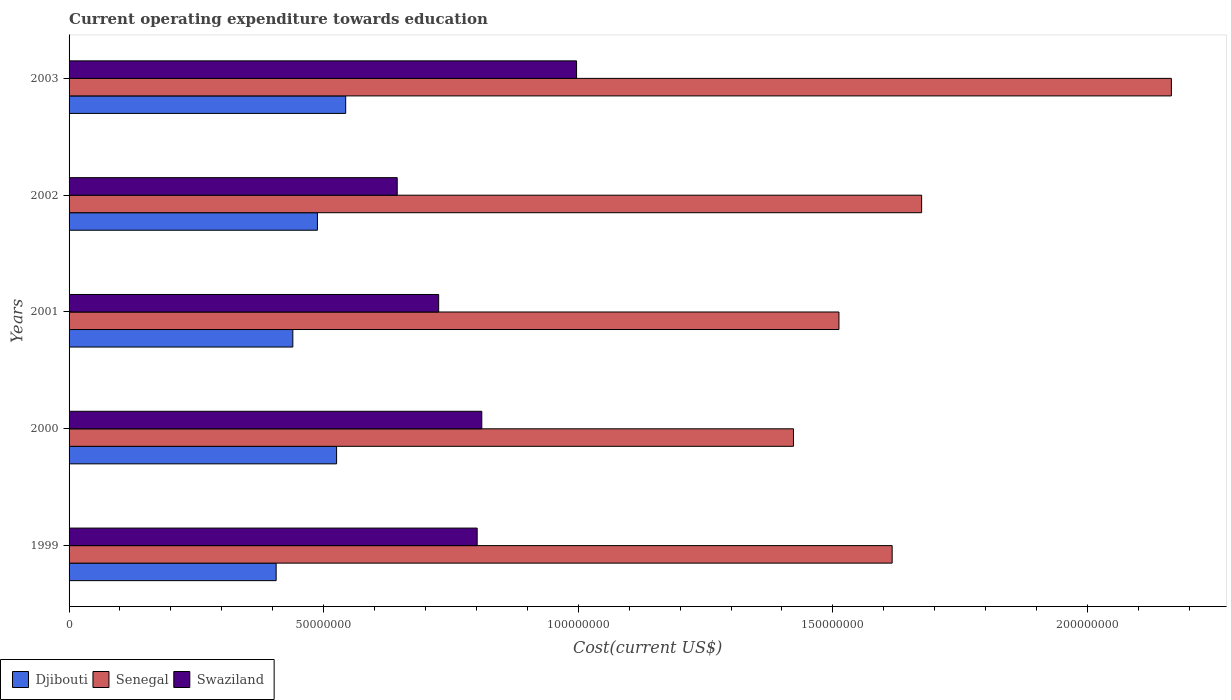In how many cases, is the number of bars for a given year not equal to the number of legend labels?
Ensure brevity in your answer.  0. What is the expenditure towards education in Senegal in 2000?
Ensure brevity in your answer.  1.42e+08. Across all years, what is the maximum expenditure towards education in Swaziland?
Provide a succinct answer. 9.97e+07. Across all years, what is the minimum expenditure towards education in Djibouti?
Provide a short and direct response. 4.07e+07. What is the total expenditure towards education in Swaziland in the graph?
Provide a short and direct response. 3.98e+08. What is the difference between the expenditure towards education in Swaziland in 1999 and that in 2001?
Offer a terse response. 7.56e+06. What is the difference between the expenditure towards education in Swaziland in 1999 and the expenditure towards education in Djibouti in 2002?
Your answer should be very brief. 3.14e+07. What is the average expenditure towards education in Senegal per year?
Your response must be concise. 1.68e+08. In the year 2002, what is the difference between the expenditure towards education in Djibouti and expenditure towards education in Senegal?
Provide a succinct answer. -1.19e+08. In how many years, is the expenditure towards education in Swaziland greater than 80000000 US$?
Keep it short and to the point. 3. What is the ratio of the expenditure towards education in Swaziland in 1999 to that in 2001?
Provide a succinct answer. 1.1. Is the expenditure towards education in Senegal in 1999 less than that in 2002?
Make the answer very short. Yes. Is the difference between the expenditure towards education in Djibouti in 2000 and 2003 greater than the difference between the expenditure towards education in Senegal in 2000 and 2003?
Your answer should be very brief. Yes. What is the difference between the highest and the second highest expenditure towards education in Swaziland?
Ensure brevity in your answer.  1.86e+07. What is the difference between the highest and the lowest expenditure towards education in Senegal?
Your response must be concise. 7.42e+07. What does the 3rd bar from the top in 2000 represents?
Provide a short and direct response. Djibouti. What does the 3rd bar from the bottom in 2003 represents?
Ensure brevity in your answer.  Swaziland. Is it the case that in every year, the sum of the expenditure towards education in Djibouti and expenditure towards education in Senegal is greater than the expenditure towards education in Swaziland?
Provide a short and direct response. Yes. How many bars are there?
Offer a very short reply. 15. Are all the bars in the graph horizontal?
Your answer should be very brief. Yes. How many years are there in the graph?
Provide a succinct answer. 5. Does the graph contain any zero values?
Give a very brief answer. No. What is the title of the graph?
Make the answer very short. Current operating expenditure towards education. Does "St. Martin (French part)" appear as one of the legend labels in the graph?
Make the answer very short. No. What is the label or title of the X-axis?
Give a very brief answer. Cost(current US$). What is the label or title of the Y-axis?
Your answer should be compact. Years. What is the Cost(current US$) of Djibouti in 1999?
Offer a terse response. 4.07e+07. What is the Cost(current US$) of Senegal in 1999?
Your answer should be very brief. 1.62e+08. What is the Cost(current US$) in Swaziland in 1999?
Provide a short and direct response. 8.01e+07. What is the Cost(current US$) of Djibouti in 2000?
Your response must be concise. 5.25e+07. What is the Cost(current US$) in Senegal in 2000?
Provide a succinct answer. 1.42e+08. What is the Cost(current US$) in Swaziland in 2000?
Provide a short and direct response. 8.11e+07. What is the Cost(current US$) in Djibouti in 2001?
Ensure brevity in your answer.  4.39e+07. What is the Cost(current US$) of Senegal in 2001?
Provide a short and direct response. 1.51e+08. What is the Cost(current US$) of Swaziland in 2001?
Keep it short and to the point. 7.26e+07. What is the Cost(current US$) of Djibouti in 2002?
Offer a very short reply. 4.88e+07. What is the Cost(current US$) in Senegal in 2002?
Ensure brevity in your answer.  1.67e+08. What is the Cost(current US$) of Swaziland in 2002?
Offer a terse response. 6.44e+07. What is the Cost(current US$) in Djibouti in 2003?
Your answer should be compact. 5.43e+07. What is the Cost(current US$) of Senegal in 2003?
Make the answer very short. 2.16e+08. What is the Cost(current US$) in Swaziland in 2003?
Your answer should be compact. 9.97e+07. Across all years, what is the maximum Cost(current US$) of Djibouti?
Offer a terse response. 5.43e+07. Across all years, what is the maximum Cost(current US$) in Senegal?
Give a very brief answer. 2.16e+08. Across all years, what is the maximum Cost(current US$) of Swaziland?
Offer a very short reply. 9.97e+07. Across all years, what is the minimum Cost(current US$) of Djibouti?
Provide a short and direct response. 4.07e+07. Across all years, what is the minimum Cost(current US$) in Senegal?
Provide a short and direct response. 1.42e+08. Across all years, what is the minimum Cost(current US$) in Swaziland?
Provide a succinct answer. 6.44e+07. What is the total Cost(current US$) of Djibouti in the graph?
Make the answer very short. 2.40e+08. What is the total Cost(current US$) in Senegal in the graph?
Keep it short and to the point. 8.39e+08. What is the total Cost(current US$) of Swaziland in the graph?
Your answer should be compact. 3.98e+08. What is the difference between the Cost(current US$) of Djibouti in 1999 and that in 2000?
Provide a succinct answer. -1.19e+07. What is the difference between the Cost(current US$) in Senegal in 1999 and that in 2000?
Provide a short and direct response. 1.94e+07. What is the difference between the Cost(current US$) in Swaziland in 1999 and that in 2000?
Provide a short and direct response. -9.08e+05. What is the difference between the Cost(current US$) in Djibouti in 1999 and that in 2001?
Keep it short and to the point. -3.27e+06. What is the difference between the Cost(current US$) of Senegal in 1999 and that in 2001?
Make the answer very short. 1.04e+07. What is the difference between the Cost(current US$) in Swaziland in 1999 and that in 2001?
Make the answer very short. 7.56e+06. What is the difference between the Cost(current US$) in Djibouti in 1999 and that in 2002?
Offer a very short reply. -8.11e+06. What is the difference between the Cost(current US$) of Senegal in 1999 and that in 2002?
Ensure brevity in your answer.  -5.79e+06. What is the difference between the Cost(current US$) of Swaziland in 1999 and that in 2002?
Your answer should be very brief. 1.57e+07. What is the difference between the Cost(current US$) of Djibouti in 1999 and that in 2003?
Your answer should be compact. -1.37e+07. What is the difference between the Cost(current US$) of Senegal in 1999 and that in 2003?
Your answer should be compact. -5.48e+07. What is the difference between the Cost(current US$) in Swaziland in 1999 and that in 2003?
Ensure brevity in your answer.  -1.95e+07. What is the difference between the Cost(current US$) in Djibouti in 2000 and that in 2001?
Give a very brief answer. 8.60e+06. What is the difference between the Cost(current US$) in Senegal in 2000 and that in 2001?
Keep it short and to the point. -8.93e+06. What is the difference between the Cost(current US$) of Swaziland in 2000 and that in 2001?
Offer a very short reply. 8.47e+06. What is the difference between the Cost(current US$) of Djibouti in 2000 and that in 2002?
Offer a terse response. 3.76e+06. What is the difference between the Cost(current US$) in Senegal in 2000 and that in 2002?
Your response must be concise. -2.52e+07. What is the difference between the Cost(current US$) in Swaziland in 2000 and that in 2002?
Provide a short and direct response. 1.66e+07. What is the difference between the Cost(current US$) of Djibouti in 2000 and that in 2003?
Make the answer very short. -1.79e+06. What is the difference between the Cost(current US$) of Senegal in 2000 and that in 2003?
Provide a short and direct response. -7.42e+07. What is the difference between the Cost(current US$) in Swaziland in 2000 and that in 2003?
Provide a short and direct response. -1.86e+07. What is the difference between the Cost(current US$) of Djibouti in 2001 and that in 2002?
Give a very brief answer. -4.83e+06. What is the difference between the Cost(current US$) in Senegal in 2001 and that in 2002?
Make the answer very short. -1.62e+07. What is the difference between the Cost(current US$) in Swaziland in 2001 and that in 2002?
Offer a terse response. 8.14e+06. What is the difference between the Cost(current US$) in Djibouti in 2001 and that in 2003?
Ensure brevity in your answer.  -1.04e+07. What is the difference between the Cost(current US$) in Senegal in 2001 and that in 2003?
Offer a very short reply. -6.53e+07. What is the difference between the Cost(current US$) of Swaziland in 2001 and that in 2003?
Keep it short and to the point. -2.71e+07. What is the difference between the Cost(current US$) of Djibouti in 2002 and that in 2003?
Offer a very short reply. -5.55e+06. What is the difference between the Cost(current US$) in Senegal in 2002 and that in 2003?
Provide a succinct answer. -4.90e+07. What is the difference between the Cost(current US$) of Swaziland in 2002 and that in 2003?
Provide a short and direct response. -3.52e+07. What is the difference between the Cost(current US$) of Djibouti in 1999 and the Cost(current US$) of Senegal in 2000?
Provide a short and direct response. -1.02e+08. What is the difference between the Cost(current US$) in Djibouti in 1999 and the Cost(current US$) in Swaziland in 2000?
Your answer should be very brief. -4.04e+07. What is the difference between the Cost(current US$) of Senegal in 1999 and the Cost(current US$) of Swaziland in 2000?
Give a very brief answer. 8.06e+07. What is the difference between the Cost(current US$) in Djibouti in 1999 and the Cost(current US$) in Senegal in 2001?
Your response must be concise. -1.11e+08. What is the difference between the Cost(current US$) in Djibouti in 1999 and the Cost(current US$) in Swaziland in 2001?
Ensure brevity in your answer.  -3.19e+07. What is the difference between the Cost(current US$) in Senegal in 1999 and the Cost(current US$) in Swaziland in 2001?
Your answer should be compact. 8.91e+07. What is the difference between the Cost(current US$) in Djibouti in 1999 and the Cost(current US$) in Senegal in 2002?
Provide a short and direct response. -1.27e+08. What is the difference between the Cost(current US$) in Djibouti in 1999 and the Cost(current US$) in Swaziland in 2002?
Your answer should be compact. -2.38e+07. What is the difference between the Cost(current US$) of Senegal in 1999 and the Cost(current US$) of Swaziland in 2002?
Offer a very short reply. 9.72e+07. What is the difference between the Cost(current US$) in Djibouti in 1999 and the Cost(current US$) in Senegal in 2003?
Keep it short and to the point. -1.76e+08. What is the difference between the Cost(current US$) of Djibouti in 1999 and the Cost(current US$) of Swaziland in 2003?
Offer a very short reply. -5.90e+07. What is the difference between the Cost(current US$) of Senegal in 1999 and the Cost(current US$) of Swaziland in 2003?
Provide a succinct answer. 6.20e+07. What is the difference between the Cost(current US$) of Djibouti in 2000 and the Cost(current US$) of Senegal in 2001?
Provide a succinct answer. -9.87e+07. What is the difference between the Cost(current US$) of Djibouti in 2000 and the Cost(current US$) of Swaziland in 2001?
Ensure brevity in your answer.  -2.00e+07. What is the difference between the Cost(current US$) of Senegal in 2000 and the Cost(current US$) of Swaziland in 2001?
Ensure brevity in your answer.  6.97e+07. What is the difference between the Cost(current US$) in Djibouti in 2000 and the Cost(current US$) in Senegal in 2002?
Offer a terse response. -1.15e+08. What is the difference between the Cost(current US$) in Djibouti in 2000 and the Cost(current US$) in Swaziland in 2002?
Give a very brief answer. -1.19e+07. What is the difference between the Cost(current US$) of Senegal in 2000 and the Cost(current US$) of Swaziland in 2002?
Your answer should be very brief. 7.78e+07. What is the difference between the Cost(current US$) in Djibouti in 2000 and the Cost(current US$) in Senegal in 2003?
Keep it short and to the point. -1.64e+08. What is the difference between the Cost(current US$) of Djibouti in 2000 and the Cost(current US$) of Swaziland in 2003?
Give a very brief answer. -4.71e+07. What is the difference between the Cost(current US$) of Senegal in 2000 and the Cost(current US$) of Swaziland in 2003?
Your answer should be compact. 4.26e+07. What is the difference between the Cost(current US$) of Djibouti in 2001 and the Cost(current US$) of Senegal in 2002?
Your answer should be very brief. -1.23e+08. What is the difference between the Cost(current US$) in Djibouti in 2001 and the Cost(current US$) in Swaziland in 2002?
Give a very brief answer. -2.05e+07. What is the difference between the Cost(current US$) of Senegal in 2001 and the Cost(current US$) of Swaziland in 2002?
Your answer should be very brief. 8.67e+07. What is the difference between the Cost(current US$) of Djibouti in 2001 and the Cost(current US$) of Senegal in 2003?
Provide a short and direct response. -1.73e+08. What is the difference between the Cost(current US$) of Djibouti in 2001 and the Cost(current US$) of Swaziland in 2003?
Your answer should be very brief. -5.57e+07. What is the difference between the Cost(current US$) of Senegal in 2001 and the Cost(current US$) of Swaziland in 2003?
Give a very brief answer. 5.15e+07. What is the difference between the Cost(current US$) in Djibouti in 2002 and the Cost(current US$) in Senegal in 2003?
Make the answer very short. -1.68e+08. What is the difference between the Cost(current US$) in Djibouti in 2002 and the Cost(current US$) in Swaziland in 2003?
Offer a terse response. -5.09e+07. What is the difference between the Cost(current US$) in Senegal in 2002 and the Cost(current US$) in Swaziland in 2003?
Provide a succinct answer. 6.78e+07. What is the average Cost(current US$) in Djibouti per year?
Your answer should be compact. 4.80e+07. What is the average Cost(current US$) of Senegal per year?
Ensure brevity in your answer.  1.68e+08. What is the average Cost(current US$) of Swaziland per year?
Your answer should be very brief. 7.96e+07. In the year 1999, what is the difference between the Cost(current US$) of Djibouti and Cost(current US$) of Senegal?
Give a very brief answer. -1.21e+08. In the year 1999, what is the difference between the Cost(current US$) in Djibouti and Cost(current US$) in Swaziland?
Keep it short and to the point. -3.95e+07. In the year 1999, what is the difference between the Cost(current US$) in Senegal and Cost(current US$) in Swaziland?
Your answer should be compact. 8.15e+07. In the year 2000, what is the difference between the Cost(current US$) of Djibouti and Cost(current US$) of Senegal?
Ensure brevity in your answer.  -8.97e+07. In the year 2000, what is the difference between the Cost(current US$) in Djibouti and Cost(current US$) in Swaziland?
Make the answer very short. -2.85e+07. In the year 2000, what is the difference between the Cost(current US$) of Senegal and Cost(current US$) of Swaziland?
Your answer should be very brief. 6.12e+07. In the year 2001, what is the difference between the Cost(current US$) of Djibouti and Cost(current US$) of Senegal?
Make the answer very short. -1.07e+08. In the year 2001, what is the difference between the Cost(current US$) of Djibouti and Cost(current US$) of Swaziland?
Make the answer very short. -2.86e+07. In the year 2001, what is the difference between the Cost(current US$) of Senegal and Cost(current US$) of Swaziland?
Keep it short and to the point. 7.86e+07. In the year 2002, what is the difference between the Cost(current US$) in Djibouti and Cost(current US$) in Senegal?
Provide a succinct answer. -1.19e+08. In the year 2002, what is the difference between the Cost(current US$) of Djibouti and Cost(current US$) of Swaziland?
Make the answer very short. -1.57e+07. In the year 2002, what is the difference between the Cost(current US$) in Senegal and Cost(current US$) in Swaziland?
Your answer should be very brief. 1.03e+08. In the year 2003, what is the difference between the Cost(current US$) of Djibouti and Cost(current US$) of Senegal?
Your response must be concise. -1.62e+08. In the year 2003, what is the difference between the Cost(current US$) in Djibouti and Cost(current US$) in Swaziland?
Offer a terse response. -4.53e+07. In the year 2003, what is the difference between the Cost(current US$) of Senegal and Cost(current US$) of Swaziland?
Give a very brief answer. 1.17e+08. What is the ratio of the Cost(current US$) in Djibouti in 1999 to that in 2000?
Provide a short and direct response. 0.77. What is the ratio of the Cost(current US$) in Senegal in 1999 to that in 2000?
Offer a terse response. 1.14. What is the ratio of the Cost(current US$) in Djibouti in 1999 to that in 2001?
Ensure brevity in your answer.  0.93. What is the ratio of the Cost(current US$) of Senegal in 1999 to that in 2001?
Your response must be concise. 1.07. What is the ratio of the Cost(current US$) in Swaziland in 1999 to that in 2001?
Make the answer very short. 1.1. What is the ratio of the Cost(current US$) in Djibouti in 1999 to that in 2002?
Provide a short and direct response. 0.83. What is the ratio of the Cost(current US$) in Senegal in 1999 to that in 2002?
Offer a very short reply. 0.97. What is the ratio of the Cost(current US$) of Swaziland in 1999 to that in 2002?
Provide a succinct answer. 1.24. What is the ratio of the Cost(current US$) in Djibouti in 1999 to that in 2003?
Your answer should be compact. 0.75. What is the ratio of the Cost(current US$) in Senegal in 1999 to that in 2003?
Your response must be concise. 0.75. What is the ratio of the Cost(current US$) of Swaziland in 1999 to that in 2003?
Your response must be concise. 0.8. What is the ratio of the Cost(current US$) in Djibouti in 2000 to that in 2001?
Offer a terse response. 1.2. What is the ratio of the Cost(current US$) of Senegal in 2000 to that in 2001?
Provide a succinct answer. 0.94. What is the ratio of the Cost(current US$) in Swaziland in 2000 to that in 2001?
Your answer should be very brief. 1.12. What is the ratio of the Cost(current US$) in Djibouti in 2000 to that in 2002?
Keep it short and to the point. 1.08. What is the ratio of the Cost(current US$) in Senegal in 2000 to that in 2002?
Your answer should be very brief. 0.85. What is the ratio of the Cost(current US$) of Swaziland in 2000 to that in 2002?
Make the answer very short. 1.26. What is the ratio of the Cost(current US$) in Djibouti in 2000 to that in 2003?
Ensure brevity in your answer.  0.97. What is the ratio of the Cost(current US$) of Senegal in 2000 to that in 2003?
Your response must be concise. 0.66. What is the ratio of the Cost(current US$) of Swaziland in 2000 to that in 2003?
Provide a succinct answer. 0.81. What is the ratio of the Cost(current US$) of Djibouti in 2001 to that in 2002?
Your answer should be very brief. 0.9. What is the ratio of the Cost(current US$) in Senegal in 2001 to that in 2002?
Provide a succinct answer. 0.9. What is the ratio of the Cost(current US$) in Swaziland in 2001 to that in 2002?
Your answer should be very brief. 1.13. What is the ratio of the Cost(current US$) of Djibouti in 2001 to that in 2003?
Keep it short and to the point. 0.81. What is the ratio of the Cost(current US$) of Senegal in 2001 to that in 2003?
Provide a short and direct response. 0.7. What is the ratio of the Cost(current US$) in Swaziland in 2001 to that in 2003?
Give a very brief answer. 0.73. What is the ratio of the Cost(current US$) in Djibouti in 2002 to that in 2003?
Make the answer very short. 0.9. What is the ratio of the Cost(current US$) in Senegal in 2002 to that in 2003?
Your answer should be very brief. 0.77. What is the ratio of the Cost(current US$) in Swaziland in 2002 to that in 2003?
Offer a terse response. 0.65. What is the difference between the highest and the second highest Cost(current US$) in Djibouti?
Your answer should be very brief. 1.79e+06. What is the difference between the highest and the second highest Cost(current US$) of Senegal?
Provide a succinct answer. 4.90e+07. What is the difference between the highest and the second highest Cost(current US$) of Swaziland?
Keep it short and to the point. 1.86e+07. What is the difference between the highest and the lowest Cost(current US$) of Djibouti?
Give a very brief answer. 1.37e+07. What is the difference between the highest and the lowest Cost(current US$) in Senegal?
Make the answer very short. 7.42e+07. What is the difference between the highest and the lowest Cost(current US$) of Swaziland?
Ensure brevity in your answer.  3.52e+07. 